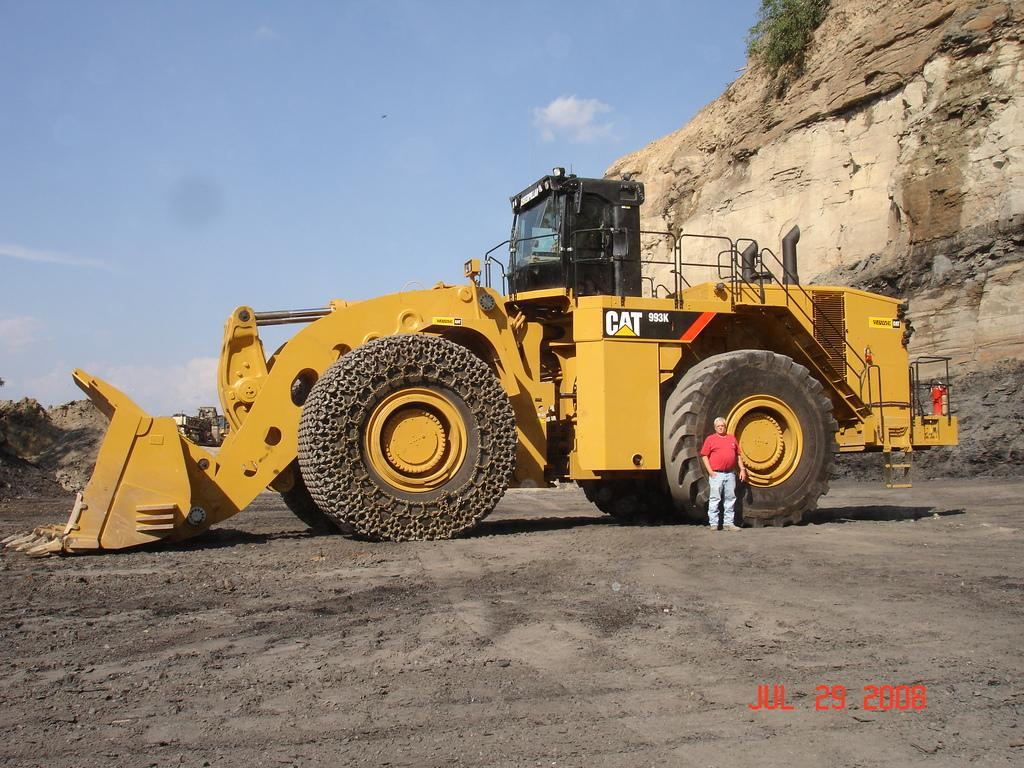What is the main subject in the center of the image? There is a crane in the center of the image. Can you describe the person on the right side of the image? There is a man on the right side of the image. What can be seen in the background of the image? There is a mountain in the background of the image. What type of truck is parked next to the crane in the image? There is no truck present in the image; it only features a crane and a man. How many family members can be seen in the image? There are no family members present in the image; it only features a crane and a man. 